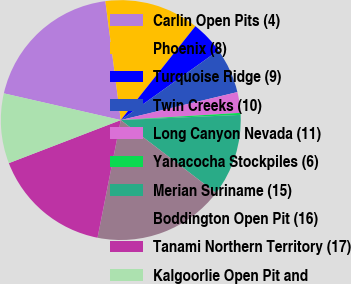Convert chart. <chart><loc_0><loc_0><loc_500><loc_500><pie_chart><fcel>Carlin Open Pits (4)<fcel>Phoenix (8)<fcel>Turquoise Ridge (9)<fcel>Twin Creeks (10)<fcel>Long Canyon Nevada (11)<fcel>Yanacocha Stockpiles (6)<fcel>Merian Suriname (15)<fcel>Boddington Open Pit (16)<fcel>Tanami Northern Territory (17)<fcel>Kalgoorlie Open Pit and<nl><fcel>19.37%<fcel>12.74%<fcel>4.45%<fcel>6.11%<fcel>2.79%<fcel>0.27%<fcel>11.08%<fcel>17.71%<fcel>16.05%<fcel>9.42%<nl></chart> 